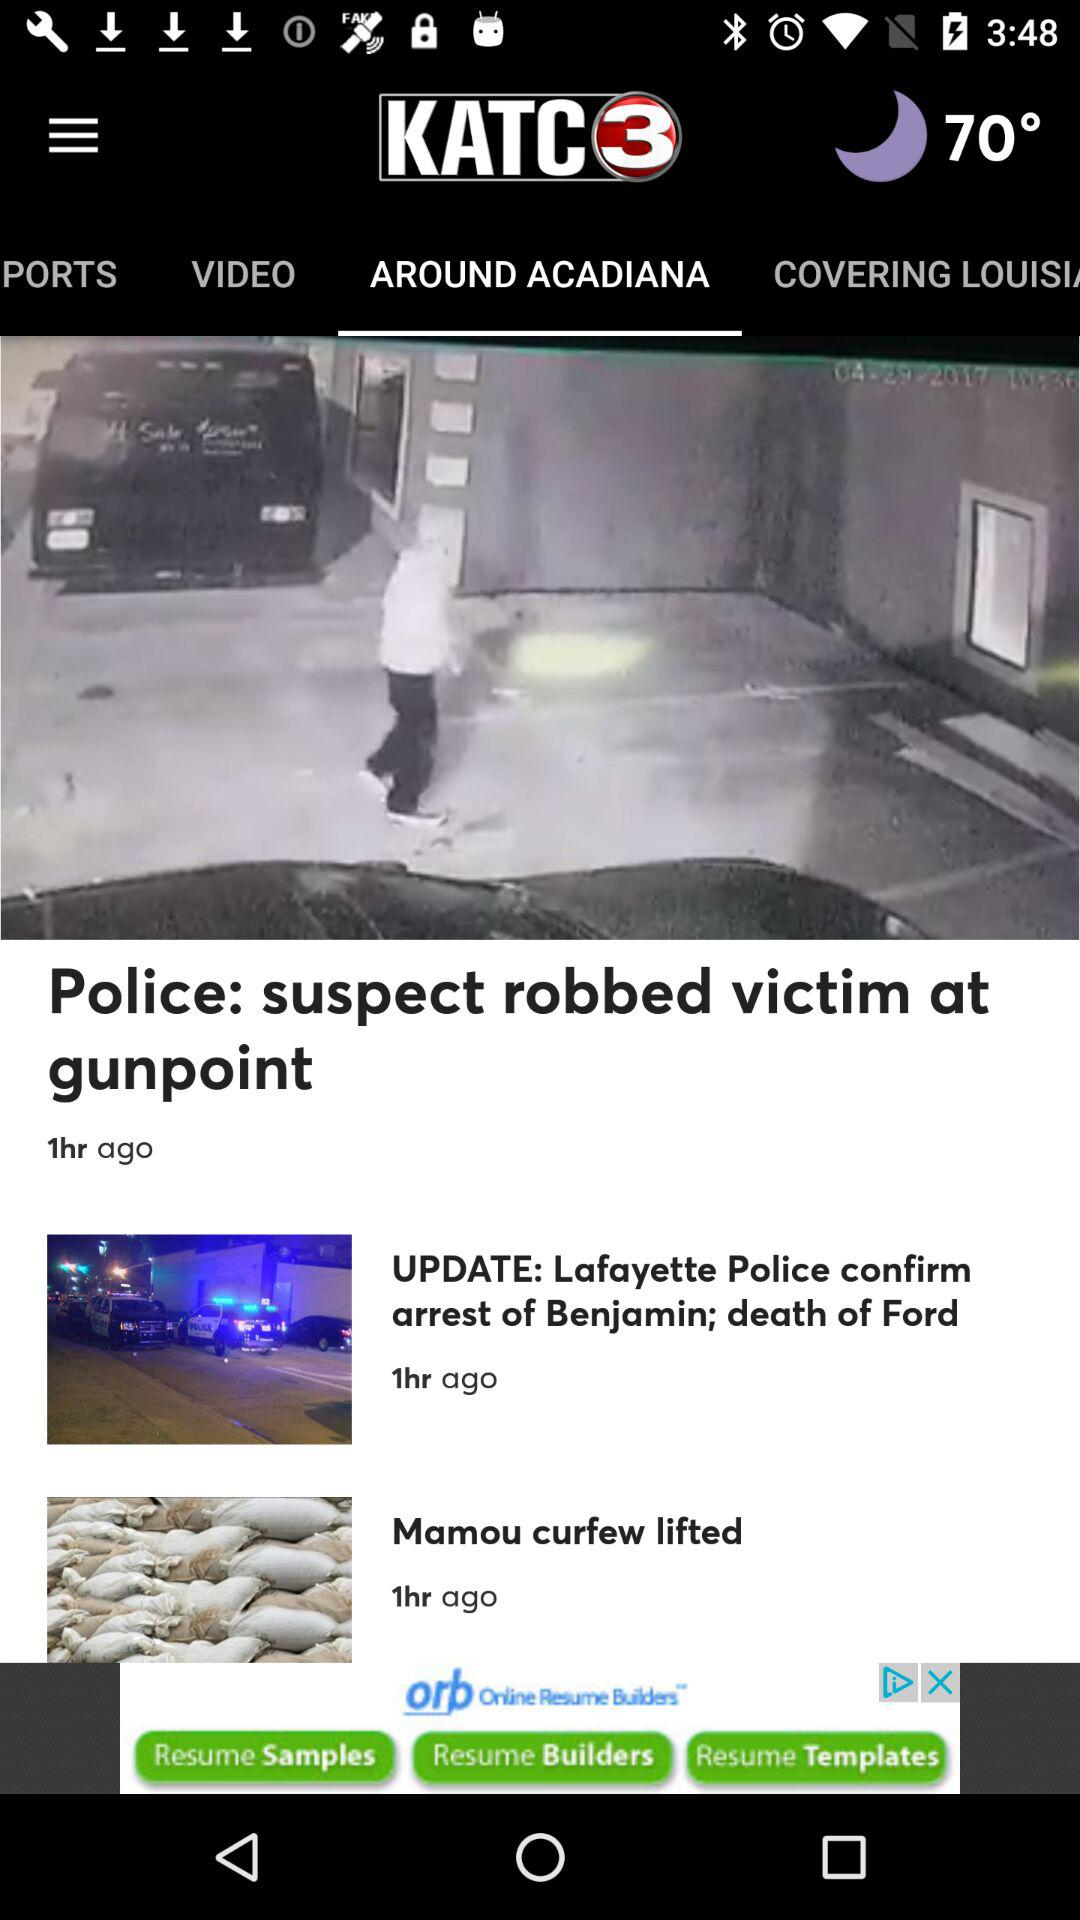How many hours ago was the first item posted?
Answer the question using a single word or phrase. 1 